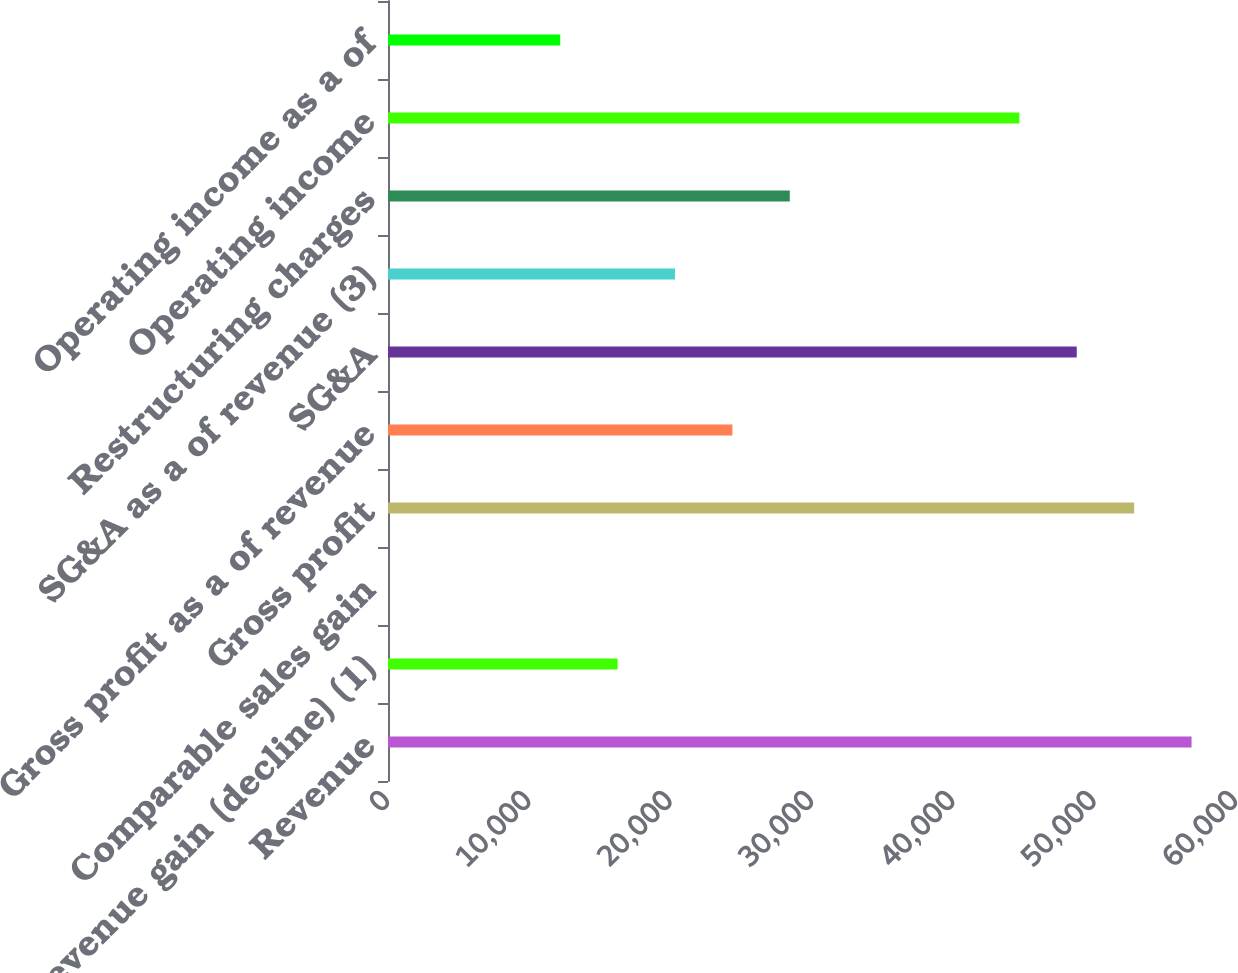Convert chart to OTSL. <chart><loc_0><loc_0><loc_500><loc_500><bar_chart><fcel>Revenue<fcel>Revenue gain (decline) (1)<fcel>Comparable sales gain<fcel>Gross profit<fcel>Gross profit as a of revenue<fcel>SG&A<fcel>SG&A as a of revenue (3)<fcel>Restructuring charges<fcel>Operating income<fcel>Operating income as a of<nl><fcel>56855<fcel>16245<fcel>1<fcel>52794<fcel>24367<fcel>48733<fcel>20306<fcel>28428<fcel>44672<fcel>12184<nl></chart> 